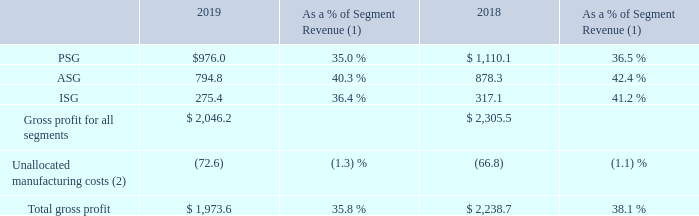Gross Profit and Gross Margin (exclusive of amortization of acquisition-related intangible assets described below)
Our gross profit by reportable segment was as follows (dollars in millions):
(1) Certain of the amounts may not total due to rounding of individual amounts. (2) Unallocated manufacturing costs are presented as a percentage of total revenue (includes expensing of the fair market value step-up of inventory of $19.6 million during 2019 and $1.0 million during 2018).
The decrease in gross profit of $265.1 million, or approximately 12%, was primarily due to the impact of the decrease in sales volume, higher fixed costs due to the expansion in our manufacturing capacity as well as the expensing of $19.6 million excess over book value of inventory, commonly referred to as the fair market value step-up, from the Quantenna acquisition.
Gross margin decreased to 35.8% during 2019 compared to 38.1% during 2018. The decrease was due to a competitive pricing environment resulting in a decline in average selling prices, higher demand for lower margin products, increased manufacturing costs due to a higher mix of external manufacturing and decreased demand for our products, as explained in the revenue section.
How much was the expensing of the fair market value step-up of inventory during 2019? $19.6 million. How much was the expensing of the fair market value step-up of inventory during 2019? $1.0 million. What is the gross profit from PSG in 2019?
Answer scale should be: million. $976.0. What is the change in gross profit from PSG from 2018 to 2019?
Answer scale should be: million. 976.0-1,110.1
Answer: -134.1. What is the change in gross profit from ASG from 2018 to 2019?
Answer scale should be: million. 794.8-878.3
Answer: -83.5. What is the average gross profit from PSG for 2018 and 2019?
Answer scale should be: million. (976.0+1,110.1) / 2
Answer: 1043.05. 